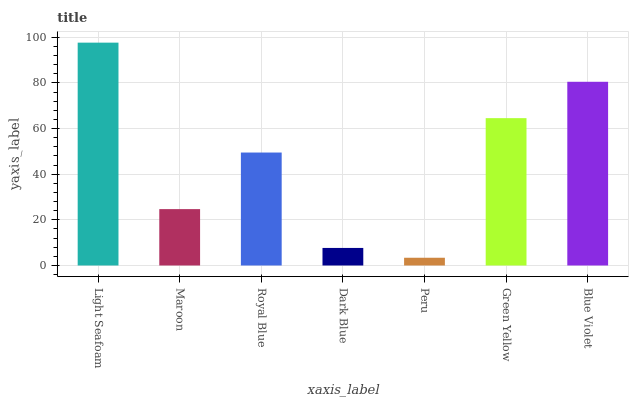Is Peru the minimum?
Answer yes or no. Yes. Is Light Seafoam the maximum?
Answer yes or no. Yes. Is Maroon the minimum?
Answer yes or no. No. Is Maroon the maximum?
Answer yes or no. No. Is Light Seafoam greater than Maroon?
Answer yes or no. Yes. Is Maroon less than Light Seafoam?
Answer yes or no. Yes. Is Maroon greater than Light Seafoam?
Answer yes or no. No. Is Light Seafoam less than Maroon?
Answer yes or no. No. Is Royal Blue the high median?
Answer yes or no. Yes. Is Royal Blue the low median?
Answer yes or no. Yes. Is Blue Violet the high median?
Answer yes or no. No. Is Peru the low median?
Answer yes or no. No. 